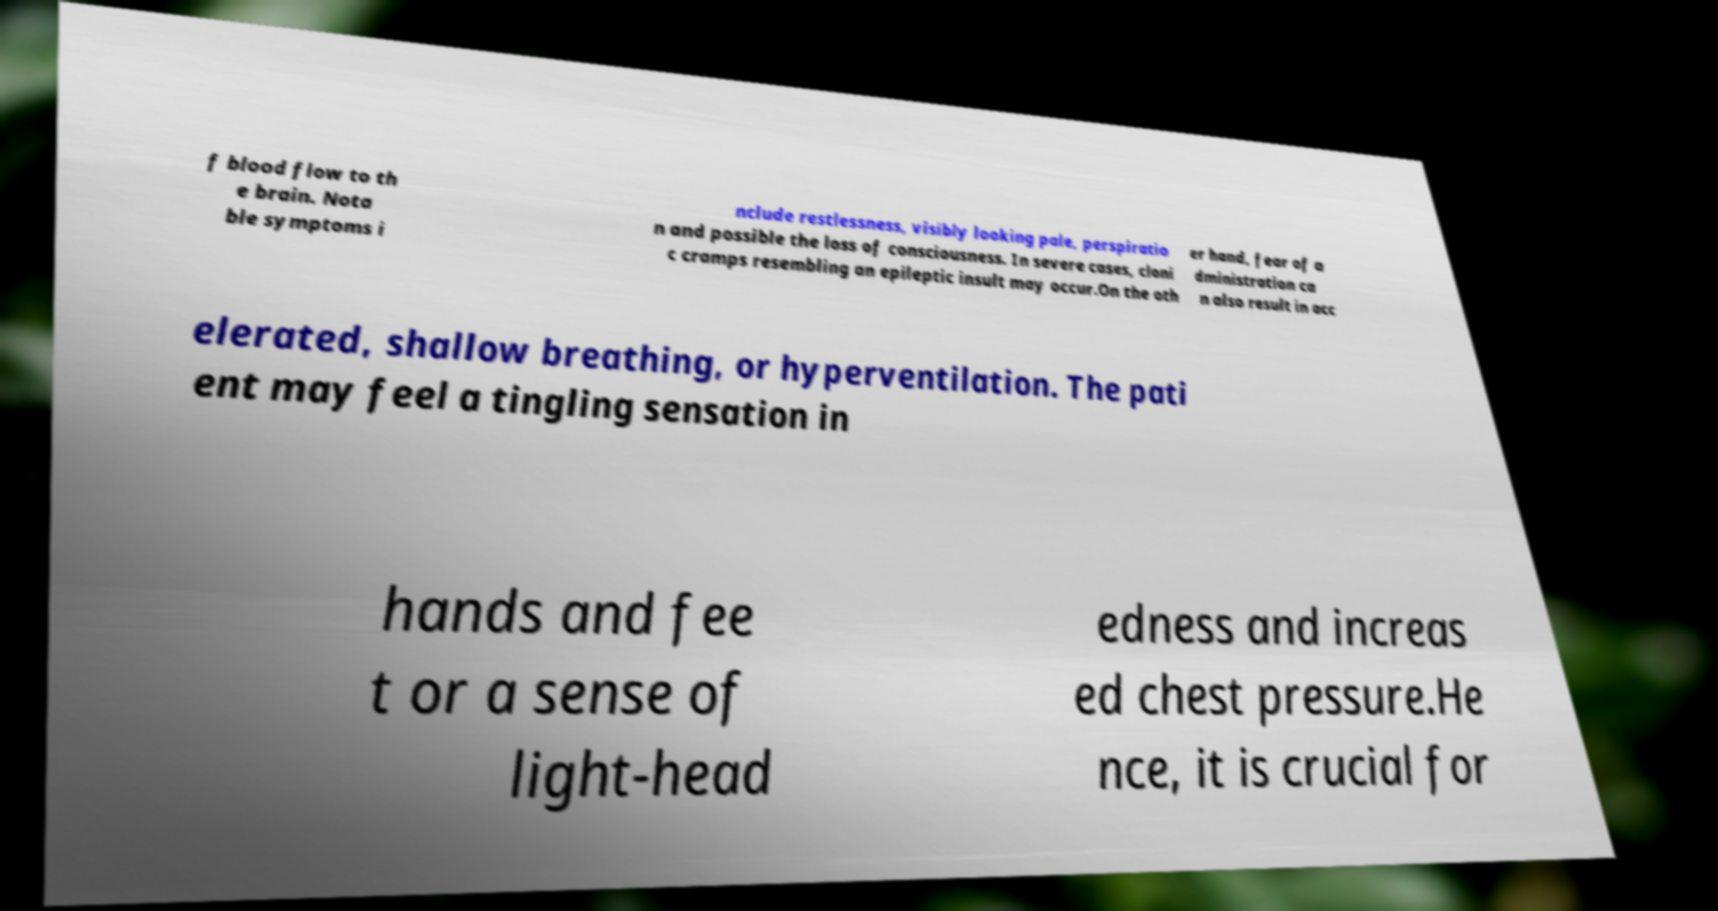What messages or text are displayed in this image? I need them in a readable, typed format. f blood flow to th e brain. Nota ble symptoms i nclude restlessness, visibly looking pale, perspiratio n and possible the loss of consciousness. In severe cases, cloni c cramps resembling an epileptic insult may occur.On the oth er hand, fear of a dministration ca n also result in acc elerated, shallow breathing, or hyperventilation. The pati ent may feel a tingling sensation in hands and fee t or a sense of light-head edness and increas ed chest pressure.He nce, it is crucial for 